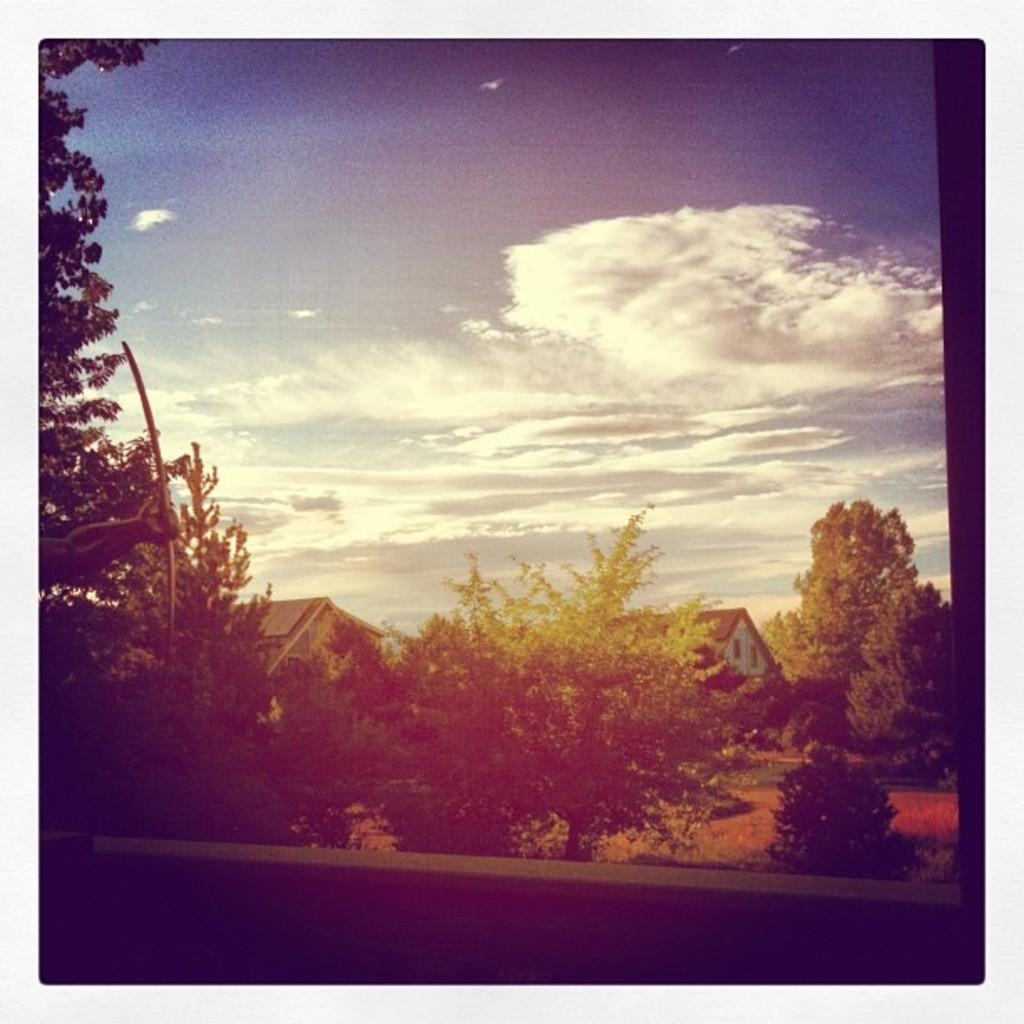What is located in the center of the image? There are seeds and trees in the center of the image. Can you describe the trees in the image? The trees are located in the center of the image. What can be seen in the background of the image? There is sky visible in the background of the image. What type of throne is depicted in the image? There is no throne present in the image. What idea is being conveyed through the seeds and trees in the image? The image does not convey any specific idea; it simply shows seeds and trees. 